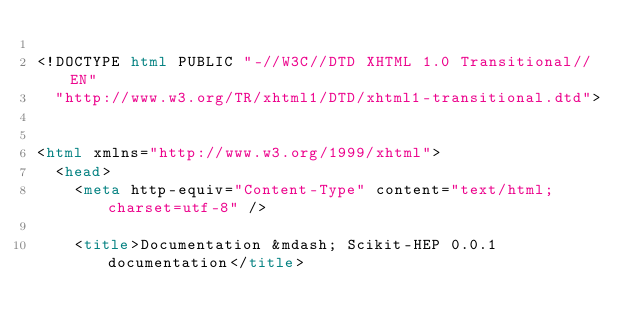Convert code to text. <code><loc_0><loc_0><loc_500><loc_500><_HTML_>
<!DOCTYPE html PUBLIC "-//W3C//DTD XHTML 1.0 Transitional//EN"
  "http://www.w3.org/TR/xhtml1/DTD/xhtml1-transitional.dtd">


<html xmlns="http://www.w3.org/1999/xhtml">
  <head>
    <meta http-equiv="Content-Type" content="text/html; charset=utf-8" />
    
    <title>Documentation &mdash; Scikit-HEP 0.0.1 documentation</title>
    </code> 